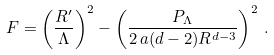Convert formula to latex. <formula><loc_0><loc_0><loc_500><loc_500>F = \left ( \frac { R ^ { \prime } } { \Lambda } \right ) ^ { 2 } - \left ( \frac { P _ { \Lambda } } { 2 \, a ( d - 2 ) R ^ { d - 3 } } \right ) ^ { 2 } \, .</formula> 